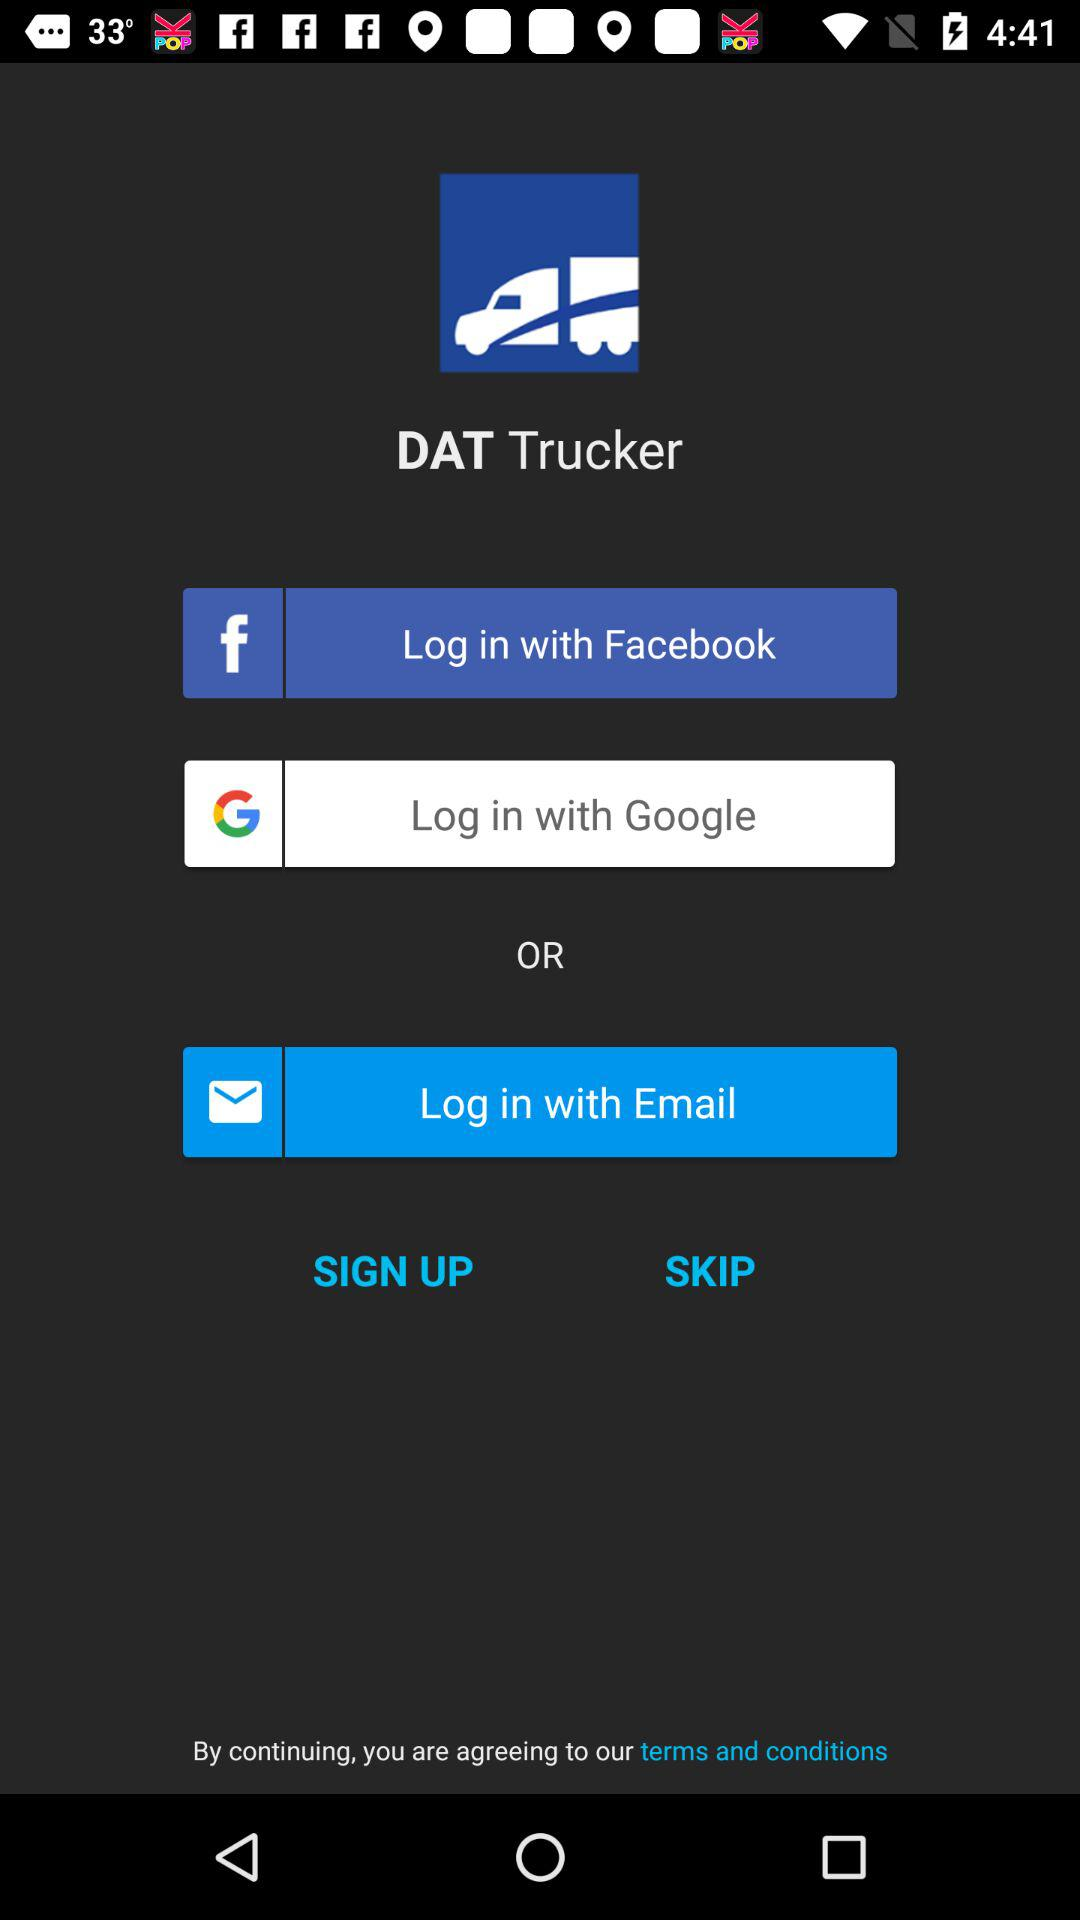Through which application can logging in be done? Logging in can be done through "Facebook" and "Google". 